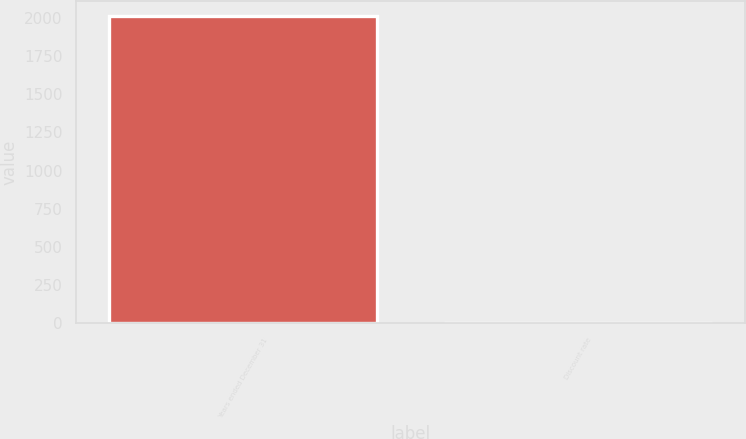Convert chart to OTSL. <chart><loc_0><loc_0><loc_500><loc_500><bar_chart><fcel>Years ended December 31<fcel>Discount rate<nl><fcel>2013<fcel>4<nl></chart> 